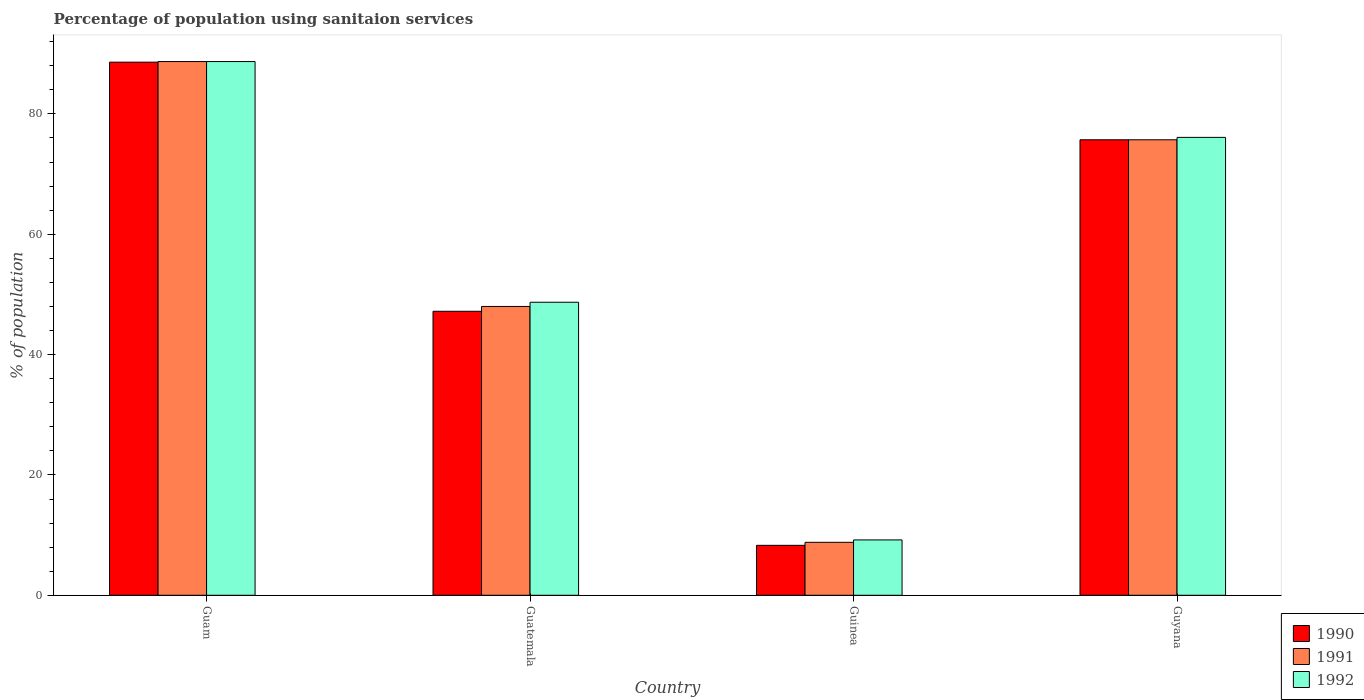How many different coloured bars are there?
Your answer should be very brief. 3. Are the number of bars on each tick of the X-axis equal?
Your answer should be very brief. Yes. How many bars are there on the 3rd tick from the left?
Provide a short and direct response. 3. What is the label of the 4th group of bars from the left?
Offer a very short reply. Guyana. In how many cases, is the number of bars for a given country not equal to the number of legend labels?
Offer a very short reply. 0. What is the percentage of population using sanitaion services in 1991 in Guinea?
Ensure brevity in your answer.  8.8. Across all countries, what is the maximum percentage of population using sanitaion services in 1992?
Provide a short and direct response. 88.7. In which country was the percentage of population using sanitaion services in 1991 maximum?
Make the answer very short. Guam. In which country was the percentage of population using sanitaion services in 1991 minimum?
Your answer should be compact. Guinea. What is the total percentage of population using sanitaion services in 1990 in the graph?
Provide a short and direct response. 219.8. What is the average percentage of population using sanitaion services in 1990 per country?
Provide a short and direct response. 54.95. What is the difference between the percentage of population using sanitaion services of/in 1990 and percentage of population using sanitaion services of/in 1991 in Guinea?
Provide a succinct answer. -0.5. What is the ratio of the percentage of population using sanitaion services in 1992 in Guatemala to that in Guinea?
Give a very brief answer. 5.29. Is the percentage of population using sanitaion services in 1991 in Guam less than that in Guinea?
Make the answer very short. No. Is the difference between the percentage of population using sanitaion services in 1990 in Guatemala and Guyana greater than the difference between the percentage of population using sanitaion services in 1991 in Guatemala and Guyana?
Your response must be concise. No. What is the difference between the highest and the second highest percentage of population using sanitaion services in 1990?
Offer a terse response. 12.9. What is the difference between the highest and the lowest percentage of population using sanitaion services in 1990?
Make the answer very short. 80.3. Is the sum of the percentage of population using sanitaion services in 1991 in Guam and Guatemala greater than the maximum percentage of population using sanitaion services in 1990 across all countries?
Your answer should be compact. Yes. What does the 1st bar from the left in Guam represents?
Offer a terse response. 1990. What does the 1st bar from the right in Guam represents?
Your answer should be very brief. 1992. How many bars are there?
Ensure brevity in your answer.  12. What is the difference between two consecutive major ticks on the Y-axis?
Your answer should be compact. 20. Are the values on the major ticks of Y-axis written in scientific E-notation?
Offer a very short reply. No. How many legend labels are there?
Offer a very short reply. 3. What is the title of the graph?
Your answer should be very brief. Percentage of population using sanitaion services. What is the label or title of the Y-axis?
Provide a short and direct response. % of population. What is the % of population of 1990 in Guam?
Offer a very short reply. 88.6. What is the % of population in 1991 in Guam?
Give a very brief answer. 88.7. What is the % of population of 1992 in Guam?
Offer a terse response. 88.7. What is the % of population in 1990 in Guatemala?
Your answer should be compact. 47.2. What is the % of population of 1991 in Guatemala?
Provide a succinct answer. 48. What is the % of population of 1992 in Guatemala?
Your answer should be compact. 48.7. What is the % of population in 1991 in Guinea?
Offer a terse response. 8.8. What is the % of population in 1990 in Guyana?
Give a very brief answer. 75.7. What is the % of population in 1991 in Guyana?
Your response must be concise. 75.7. What is the % of population of 1992 in Guyana?
Your answer should be very brief. 76.1. Across all countries, what is the maximum % of population in 1990?
Make the answer very short. 88.6. Across all countries, what is the maximum % of population of 1991?
Provide a short and direct response. 88.7. Across all countries, what is the maximum % of population of 1992?
Offer a terse response. 88.7. Across all countries, what is the minimum % of population in 1990?
Make the answer very short. 8.3. Across all countries, what is the minimum % of population of 1992?
Make the answer very short. 9.2. What is the total % of population of 1990 in the graph?
Your answer should be very brief. 219.8. What is the total % of population of 1991 in the graph?
Ensure brevity in your answer.  221.2. What is the total % of population of 1992 in the graph?
Offer a very short reply. 222.7. What is the difference between the % of population in 1990 in Guam and that in Guatemala?
Keep it short and to the point. 41.4. What is the difference between the % of population of 1991 in Guam and that in Guatemala?
Make the answer very short. 40.7. What is the difference between the % of population in 1990 in Guam and that in Guinea?
Provide a short and direct response. 80.3. What is the difference between the % of population of 1991 in Guam and that in Guinea?
Provide a succinct answer. 79.9. What is the difference between the % of population in 1992 in Guam and that in Guinea?
Ensure brevity in your answer.  79.5. What is the difference between the % of population in 1991 in Guam and that in Guyana?
Offer a terse response. 13. What is the difference between the % of population of 1990 in Guatemala and that in Guinea?
Make the answer very short. 38.9. What is the difference between the % of population in 1991 in Guatemala and that in Guinea?
Offer a very short reply. 39.2. What is the difference between the % of population in 1992 in Guatemala and that in Guinea?
Offer a terse response. 39.5. What is the difference between the % of population of 1990 in Guatemala and that in Guyana?
Give a very brief answer. -28.5. What is the difference between the % of population in 1991 in Guatemala and that in Guyana?
Provide a short and direct response. -27.7. What is the difference between the % of population of 1992 in Guatemala and that in Guyana?
Your answer should be compact. -27.4. What is the difference between the % of population in 1990 in Guinea and that in Guyana?
Your answer should be compact. -67.4. What is the difference between the % of population of 1991 in Guinea and that in Guyana?
Your answer should be compact. -66.9. What is the difference between the % of population in 1992 in Guinea and that in Guyana?
Your answer should be compact. -66.9. What is the difference between the % of population of 1990 in Guam and the % of population of 1991 in Guatemala?
Provide a short and direct response. 40.6. What is the difference between the % of population of 1990 in Guam and the % of population of 1992 in Guatemala?
Your answer should be compact. 39.9. What is the difference between the % of population of 1991 in Guam and the % of population of 1992 in Guatemala?
Offer a terse response. 40. What is the difference between the % of population in 1990 in Guam and the % of population in 1991 in Guinea?
Offer a terse response. 79.8. What is the difference between the % of population of 1990 in Guam and the % of population of 1992 in Guinea?
Keep it short and to the point. 79.4. What is the difference between the % of population of 1991 in Guam and the % of population of 1992 in Guinea?
Keep it short and to the point. 79.5. What is the difference between the % of population of 1990 in Guam and the % of population of 1991 in Guyana?
Your answer should be compact. 12.9. What is the difference between the % of population in 1990 in Guam and the % of population in 1992 in Guyana?
Offer a very short reply. 12.5. What is the difference between the % of population of 1990 in Guatemala and the % of population of 1991 in Guinea?
Ensure brevity in your answer.  38.4. What is the difference between the % of population of 1990 in Guatemala and the % of population of 1992 in Guinea?
Provide a short and direct response. 38. What is the difference between the % of population in 1991 in Guatemala and the % of population in 1992 in Guinea?
Offer a terse response. 38.8. What is the difference between the % of population in 1990 in Guatemala and the % of population in 1991 in Guyana?
Provide a short and direct response. -28.5. What is the difference between the % of population of 1990 in Guatemala and the % of population of 1992 in Guyana?
Your answer should be compact. -28.9. What is the difference between the % of population of 1991 in Guatemala and the % of population of 1992 in Guyana?
Provide a short and direct response. -28.1. What is the difference between the % of population of 1990 in Guinea and the % of population of 1991 in Guyana?
Make the answer very short. -67.4. What is the difference between the % of population in 1990 in Guinea and the % of population in 1992 in Guyana?
Provide a short and direct response. -67.8. What is the difference between the % of population in 1991 in Guinea and the % of population in 1992 in Guyana?
Provide a succinct answer. -67.3. What is the average % of population of 1990 per country?
Your response must be concise. 54.95. What is the average % of population in 1991 per country?
Your answer should be very brief. 55.3. What is the average % of population in 1992 per country?
Provide a succinct answer. 55.67. What is the difference between the % of population in 1990 and % of population in 1991 in Guam?
Provide a succinct answer. -0.1. What is the difference between the % of population in 1990 and % of population in 1992 in Guam?
Your response must be concise. -0.1. What is the difference between the % of population in 1991 and % of population in 1992 in Guam?
Provide a succinct answer. 0. What is the difference between the % of population of 1990 and % of population of 1991 in Guinea?
Provide a succinct answer. -0.5. What is the difference between the % of population of 1990 and % of population of 1992 in Guinea?
Ensure brevity in your answer.  -0.9. What is the difference between the % of population of 1990 and % of population of 1991 in Guyana?
Offer a terse response. 0. What is the difference between the % of population of 1991 and % of population of 1992 in Guyana?
Offer a terse response. -0.4. What is the ratio of the % of population of 1990 in Guam to that in Guatemala?
Your answer should be compact. 1.88. What is the ratio of the % of population of 1991 in Guam to that in Guatemala?
Your answer should be very brief. 1.85. What is the ratio of the % of population of 1992 in Guam to that in Guatemala?
Provide a succinct answer. 1.82. What is the ratio of the % of population in 1990 in Guam to that in Guinea?
Your answer should be very brief. 10.67. What is the ratio of the % of population in 1991 in Guam to that in Guinea?
Your answer should be very brief. 10.08. What is the ratio of the % of population of 1992 in Guam to that in Guinea?
Give a very brief answer. 9.64. What is the ratio of the % of population in 1990 in Guam to that in Guyana?
Offer a very short reply. 1.17. What is the ratio of the % of population of 1991 in Guam to that in Guyana?
Offer a very short reply. 1.17. What is the ratio of the % of population of 1992 in Guam to that in Guyana?
Ensure brevity in your answer.  1.17. What is the ratio of the % of population in 1990 in Guatemala to that in Guinea?
Your response must be concise. 5.69. What is the ratio of the % of population in 1991 in Guatemala to that in Guinea?
Provide a short and direct response. 5.45. What is the ratio of the % of population in 1992 in Guatemala to that in Guinea?
Offer a very short reply. 5.29. What is the ratio of the % of population in 1990 in Guatemala to that in Guyana?
Offer a very short reply. 0.62. What is the ratio of the % of population in 1991 in Guatemala to that in Guyana?
Ensure brevity in your answer.  0.63. What is the ratio of the % of population of 1992 in Guatemala to that in Guyana?
Give a very brief answer. 0.64. What is the ratio of the % of population in 1990 in Guinea to that in Guyana?
Offer a terse response. 0.11. What is the ratio of the % of population of 1991 in Guinea to that in Guyana?
Provide a succinct answer. 0.12. What is the ratio of the % of population of 1992 in Guinea to that in Guyana?
Your answer should be compact. 0.12. What is the difference between the highest and the second highest % of population of 1992?
Offer a very short reply. 12.6. What is the difference between the highest and the lowest % of population of 1990?
Your answer should be very brief. 80.3. What is the difference between the highest and the lowest % of population in 1991?
Ensure brevity in your answer.  79.9. What is the difference between the highest and the lowest % of population of 1992?
Offer a terse response. 79.5. 